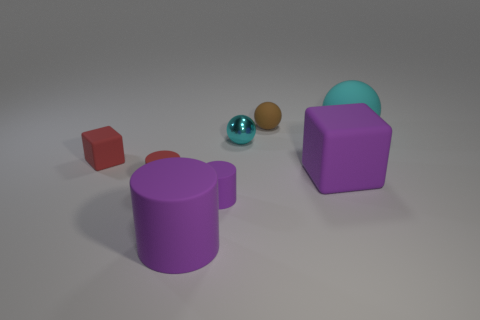How many brown rubber spheres are to the right of the tiny cyan metallic ball?
Your answer should be compact. 1. There is a brown matte thing; is its shape the same as the large matte object that is left of the small brown matte thing?
Your response must be concise. No. Is there a big blue rubber object that has the same shape as the tiny metal object?
Your answer should be very brief. No. What shape is the big matte object that is to the left of the small cylinder that is to the right of the large purple cylinder?
Provide a short and direct response. Cylinder. What is the shape of the tiny red object in front of the red rubber cube?
Your answer should be very brief. Cylinder. Is the color of the rubber ball that is in front of the brown matte thing the same as the ball that is on the left side of the brown sphere?
Provide a short and direct response. Yes. How many objects are both right of the brown thing and behind the tiny metallic ball?
Offer a very short reply. 1. There is a purple cube that is the same material as the big cyan object; what size is it?
Give a very brief answer. Large. The brown sphere is what size?
Your answer should be very brief. Small. What is the material of the big purple cylinder?
Keep it short and to the point. Rubber. 